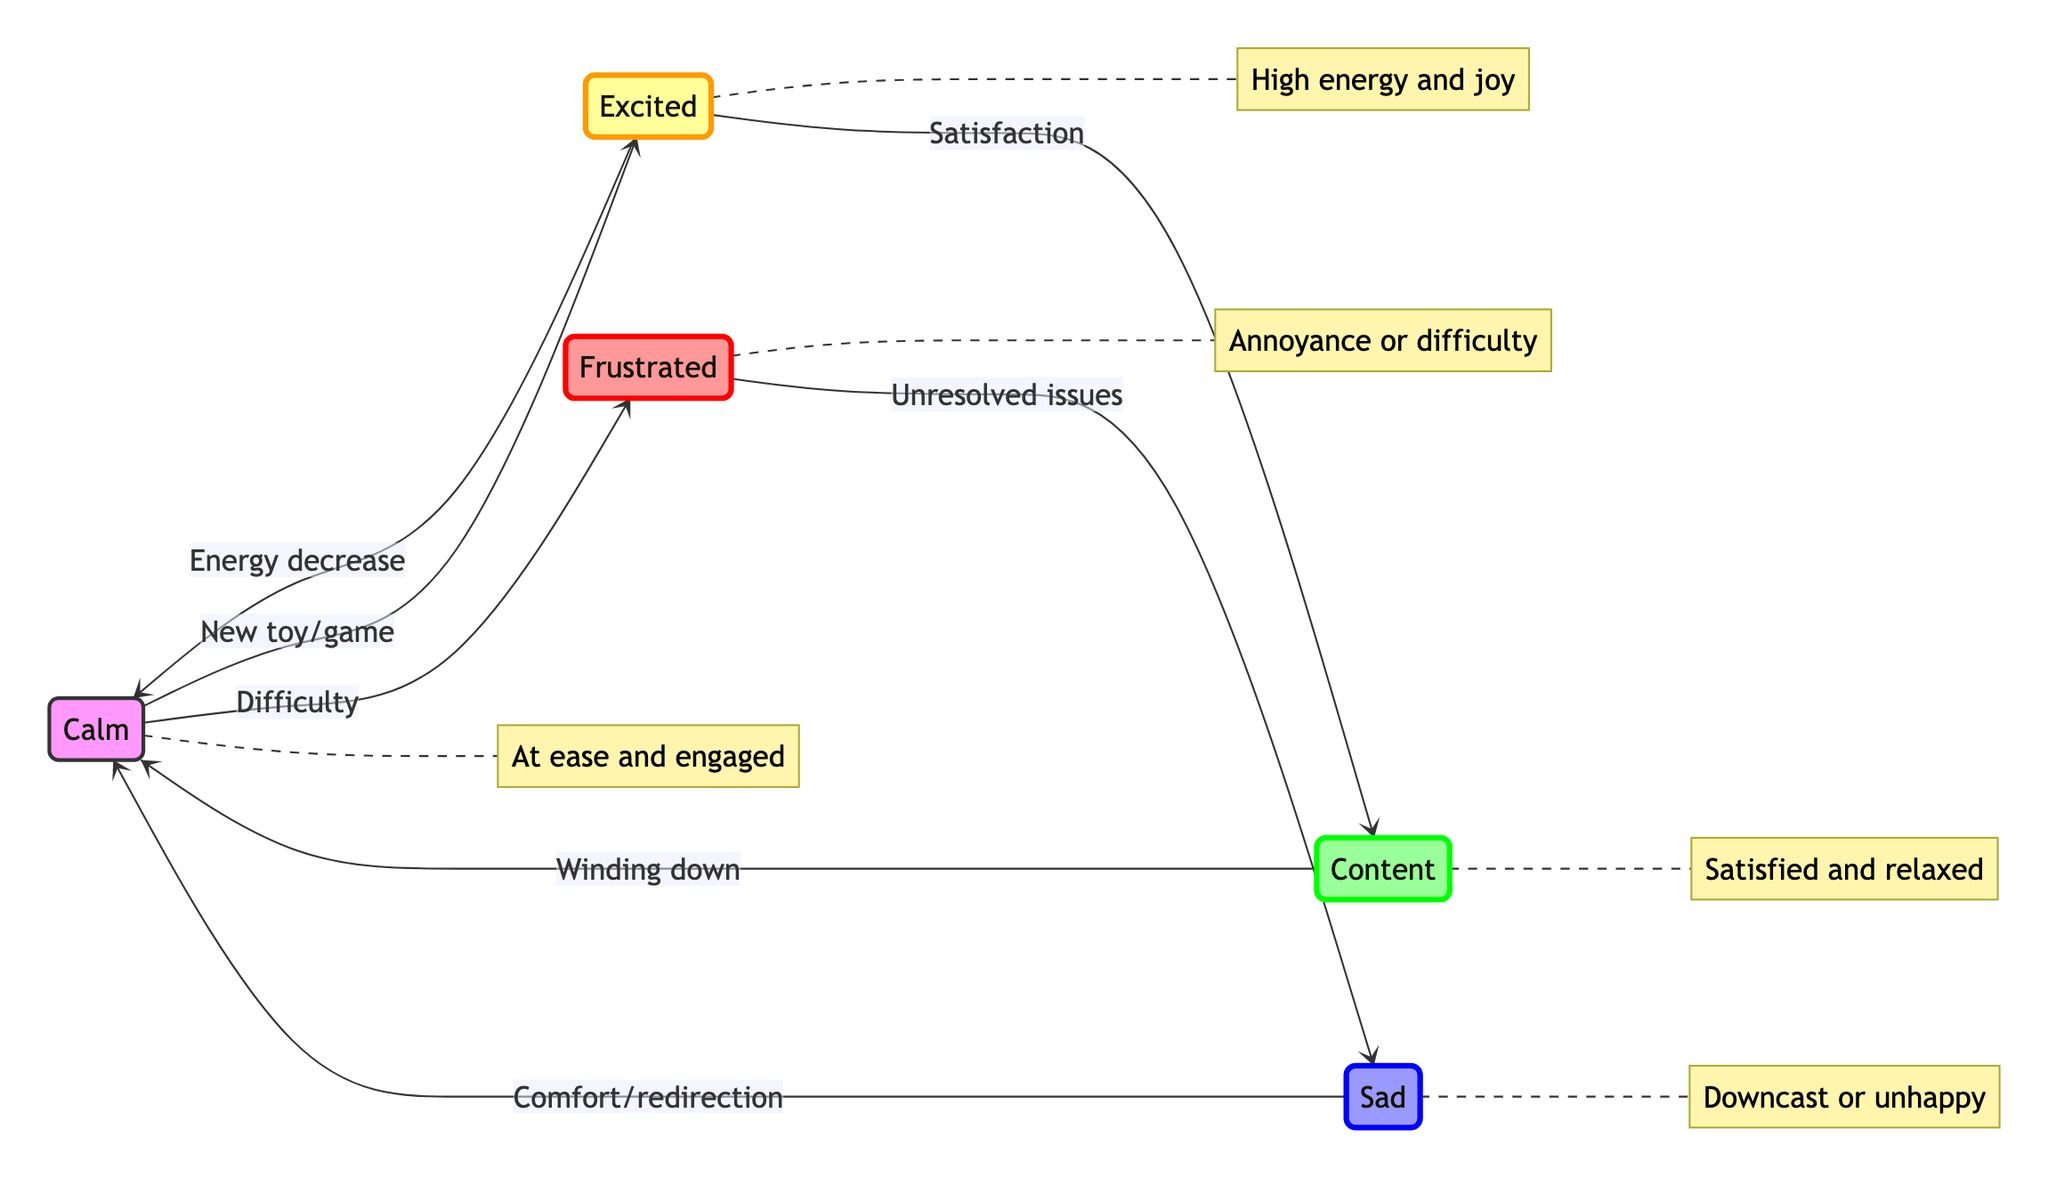What is the initial state of a child during play? The diagram indicates that the initial state of a child during play can start in the "Calm" state, which describes the child as at ease and engaged.
Answer: Calm How many total states are represented in the diagram? Upon reviewing the diagram, we can count a total of five states: Calm, Excited, Frustrated, Sad, and Content.
Answer: 5 What causes a child to transition from "Calm" to "Excited"? The transition from "Calm" to "Excited" occurs due to the introduction of a new and interesting toy or game as per the diagram.
Answer: New toy/game What is the final state after a child experiences "Sad"? The diagram shows that after being in the "Sad" state, the child can transition back to the "Calm" state when comfort from a caregiver is provided or the child is redirected to a different activity.
Answer: Calm What state does the child move to after reaching "Excited"? According to the diagram, the child can transition to "Content" after experiencing satisfaction during play, which indicates a shift from the higher energy of "Excited".
Answer: Content What triggers the transition from "Frustrated" to "Sad"? The diagram indicates that the transition from "Frustrated" to "Sad" is triggered by the inability to resolve difficulties or conflicts faced during play activities.
Answer: Unresolved issues If a child is in the "Content" state, what is the next potential state they could move to? The diagram suggests that from the "Content" state, the child may transition to the "Calm" state due to natural winding down after playtime.
Answer: Calm How does a child transition from "Excited" back to "Calm"? The transition back to "Calm" from "Excited" occurs due to a natural decrease in energy after extended playtime, as shown in the diagram.
Answer: Energy decrease 